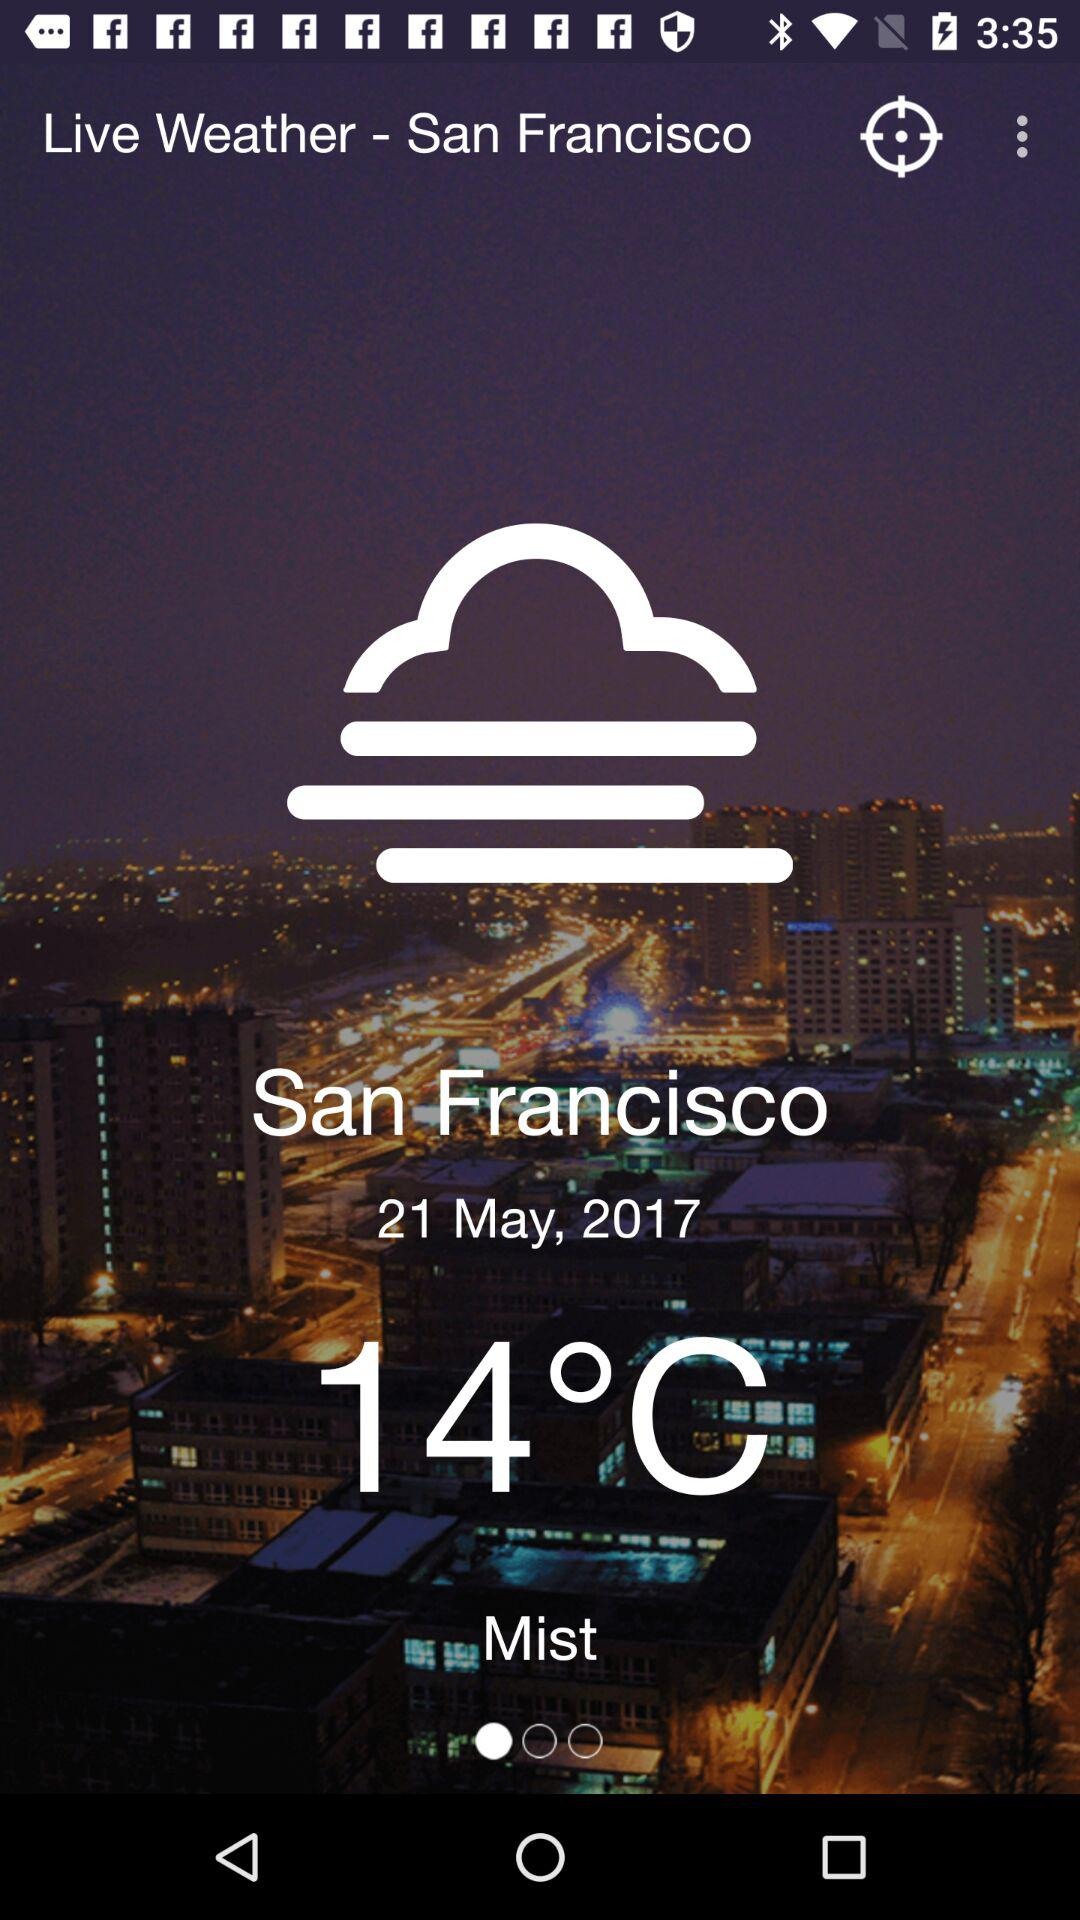How many degrees Celsius is the temperature of San Francisco?
Answer the question using a single word or phrase. 14°C 